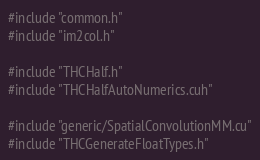Convert code to text. <code><loc_0><loc_0><loc_500><loc_500><_Cuda_>#include "common.h"
#include "im2col.h"

#include "THCHalf.h"
#include "THCHalfAutoNumerics.cuh"

#include "generic/SpatialConvolutionMM.cu"
#include "THCGenerateFloatTypes.h"
</code> 